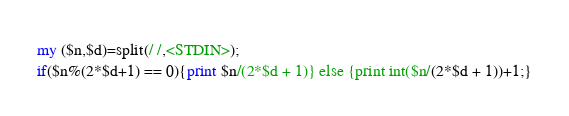<code> <loc_0><loc_0><loc_500><loc_500><_Perl_>my ($n,$d)=split(/ /,<STDIN>);
if($n%(2*$d+1) == 0){print $n/(2*$d + 1)} else {print int($n/(2*$d + 1))+1;}</code> 